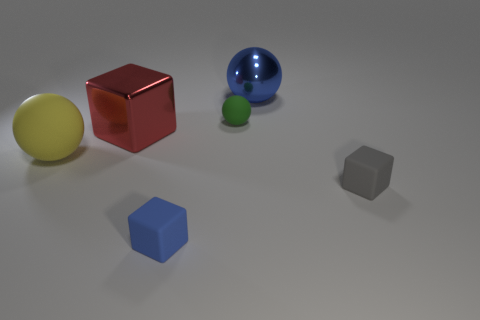Subtract 1 spheres. How many spheres are left? 2 Subtract all rubber cubes. How many cubes are left? 1 Add 3 tiny green rubber objects. How many objects exist? 9 Subtract all tiny gray matte objects. Subtract all small gray matte blocks. How many objects are left? 4 Add 3 yellow spheres. How many yellow spheres are left? 4 Add 4 small metallic things. How many small metallic things exist? 4 Subtract 0 green cubes. How many objects are left? 6 